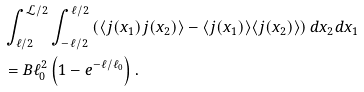<formula> <loc_0><loc_0><loc_500><loc_500>& \int _ { \ell / 2 } ^ { \mathcal { L } / 2 } \int _ { - \ell / 2 } ^ { \ell / 2 } \left ( \langle j ( x _ { 1 } ) j ( x _ { 2 } ) \rangle - \langle j ( x _ { 1 } ) \rangle \langle j ( x _ { 2 } ) \rangle \right ) d x _ { 2 } d x _ { 1 } \\ & = B \ell _ { 0 } ^ { 2 } \left ( 1 - e ^ { - \ell / \ell _ { 0 } } \right ) .</formula> 